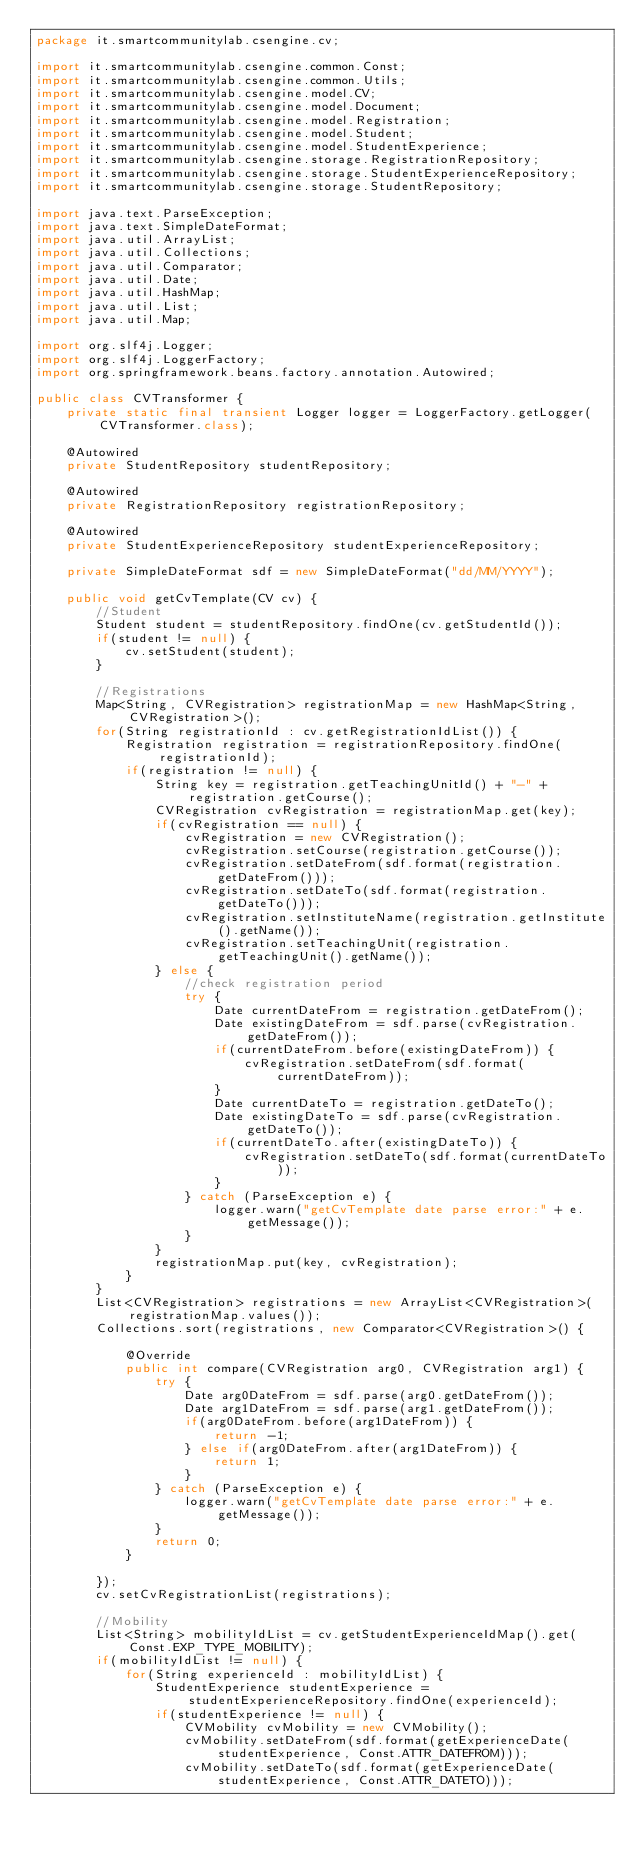<code> <loc_0><loc_0><loc_500><loc_500><_Java_>package it.smartcommunitylab.csengine.cv;

import it.smartcommunitylab.csengine.common.Const;
import it.smartcommunitylab.csengine.common.Utils;
import it.smartcommunitylab.csengine.model.CV;
import it.smartcommunitylab.csengine.model.Document;
import it.smartcommunitylab.csengine.model.Registration;
import it.smartcommunitylab.csengine.model.Student;
import it.smartcommunitylab.csengine.model.StudentExperience;
import it.smartcommunitylab.csengine.storage.RegistrationRepository;
import it.smartcommunitylab.csengine.storage.StudentExperienceRepository;
import it.smartcommunitylab.csengine.storage.StudentRepository;

import java.text.ParseException;
import java.text.SimpleDateFormat;
import java.util.ArrayList;
import java.util.Collections;
import java.util.Comparator;
import java.util.Date;
import java.util.HashMap;
import java.util.List;
import java.util.Map;

import org.slf4j.Logger;
import org.slf4j.LoggerFactory;
import org.springframework.beans.factory.annotation.Autowired;

public class CVTransformer {
	private static final transient Logger logger = LoggerFactory.getLogger(CVTransformer.class);
	
	@Autowired
	private StudentRepository studentRepository;
	
	@Autowired
	private RegistrationRepository registrationRepository;
	
	@Autowired
	private StudentExperienceRepository studentExperienceRepository;
	
	private SimpleDateFormat sdf = new SimpleDateFormat("dd/MM/YYYY");
	
	public void getCvTemplate(CV cv) {
		//Student
		Student student = studentRepository.findOne(cv.getStudentId());
		if(student != null) {
			cv.setStudent(student);
		}
		
		//Registrations
		Map<String, CVRegistration> registrationMap = new HashMap<String, CVRegistration>();
		for(String registrationId : cv.getRegistrationIdList()) {
			Registration registration = registrationRepository.findOne(registrationId);
			if(registration != null) {
				String key = registration.getTeachingUnitId() + "-" + registration.getCourse();
				CVRegistration cvRegistration = registrationMap.get(key);
				if(cvRegistration == null) {
					cvRegistration = new CVRegistration();
					cvRegistration.setCourse(registration.getCourse());
					cvRegistration.setDateFrom(sdf.format(registration.getDateFrom()));
					cvRegistration.setDateTo(sdf.format(registration.getDateTo()));
					cvRegistration.setInstituteName(registration.getInstitute().getName());
					cvRegistration.setTeachingUnit(registration.getTeachingUnit().getName());
				} else {
					//check registration period
					try {
						Date currentDateFrom = registration.getDateFrom();
						Date existingDateFrom = sdf.parse(cvRegistration.getDateFrom());
						if(currentDateFrom.before(existingDateFrom)) {
							cvRegistration.setDateFrom(sdf.format(currentDateFrom));
						}
						Date currentDateTo = registration.getDateTo();
						Date existingDateTo = sdf.parse(cvRegistration.getDateTo());
						if(currentDateTo.after(existingDateTo)) {
							cvRegistration.setDateTo(sdf.format(currentDateTo));
						}
					} catch (ParseException e) {
						logger.warn("getCvTemplate date parse error:" + e.getMessage());
					}
				}
				registrationMap.put(key, cvRegistration);
			}
		}
		List<CVRegistration> registrations = new ArrayList<CVRegistration>(registrationMap.values());
		Collections.sort(registrations, new Comparator<CVRegistration>() {

			@Override
			public int compare(CVRegistration arg0, CVRegistration arg1) {
				try {
					Date arg0DateFrom = sdf.parse(arg0.getDateFrom());
					Date arg1DateFrom = sdf.parse(arg1.getDateFrom());
					if(arg0DateFrom.before(arg1DateFrom)) {
						return -1;
					} else if(arg0DateFrom.after(arg1DateFrom)) {
						return 1;
					}
				} catch (ParseException e) {
					logger.warn("getCvTemplate date parse error:" + e.getMessage());
				}
				return 0;
			}
			
		});
		cv.setCvRegistrationList(registrations);
		
		//Mobility
		List<String> mobilityIdList = cv.getStudentExperienceIdMap().get(Const.EXP_TYPE_MOBILITY);
		if(mobilityIdList != null) {
			for(String experienceId : mobilityIdList) {
				StudentExperience studentExperience = studentExperienceRepository.findOne(experienceId);
				if(studentExperience != null) {
					CVMobility cvMobility = new CVMobility();
					cvMobility.setDateFrom(sdf.format(getExperienceDate(studentExperience, Const.ATTR_DATEFROM)));
					cvMobility.setDateTo(sdf.format(getExperienceDate(studentExperience, Const.ATTR_DATETO)));</code> 